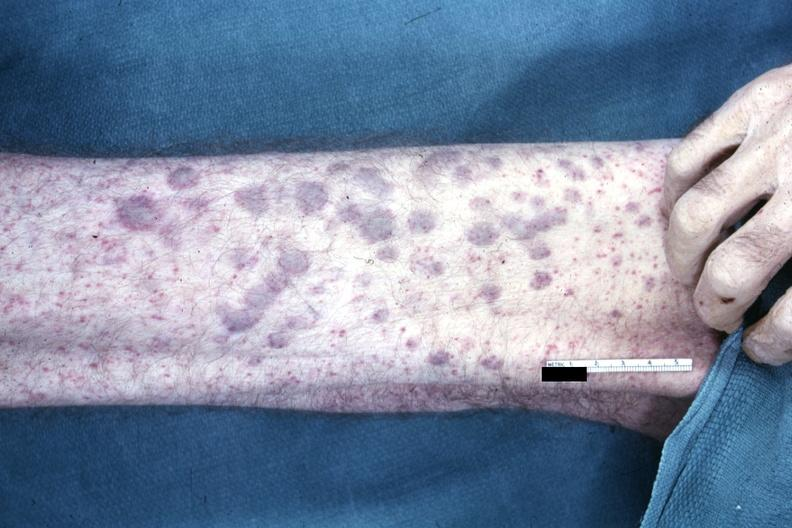what said to be aml infiltrates?
Answer the question using a single word or phrase. Not best color rendition showing elevated macular lesions on arm 